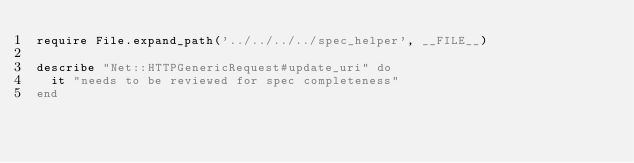Convert code to text. <code><loc_0><loc_0><loc_500><loc_500><_Ruby_>require File.expand_path('../../../../spec_helper', __FILE__)

describe "Net::HTTPGenericRequest#update_uri" do
  it "needs to be reviewed for spec completeness"
end
</code> 